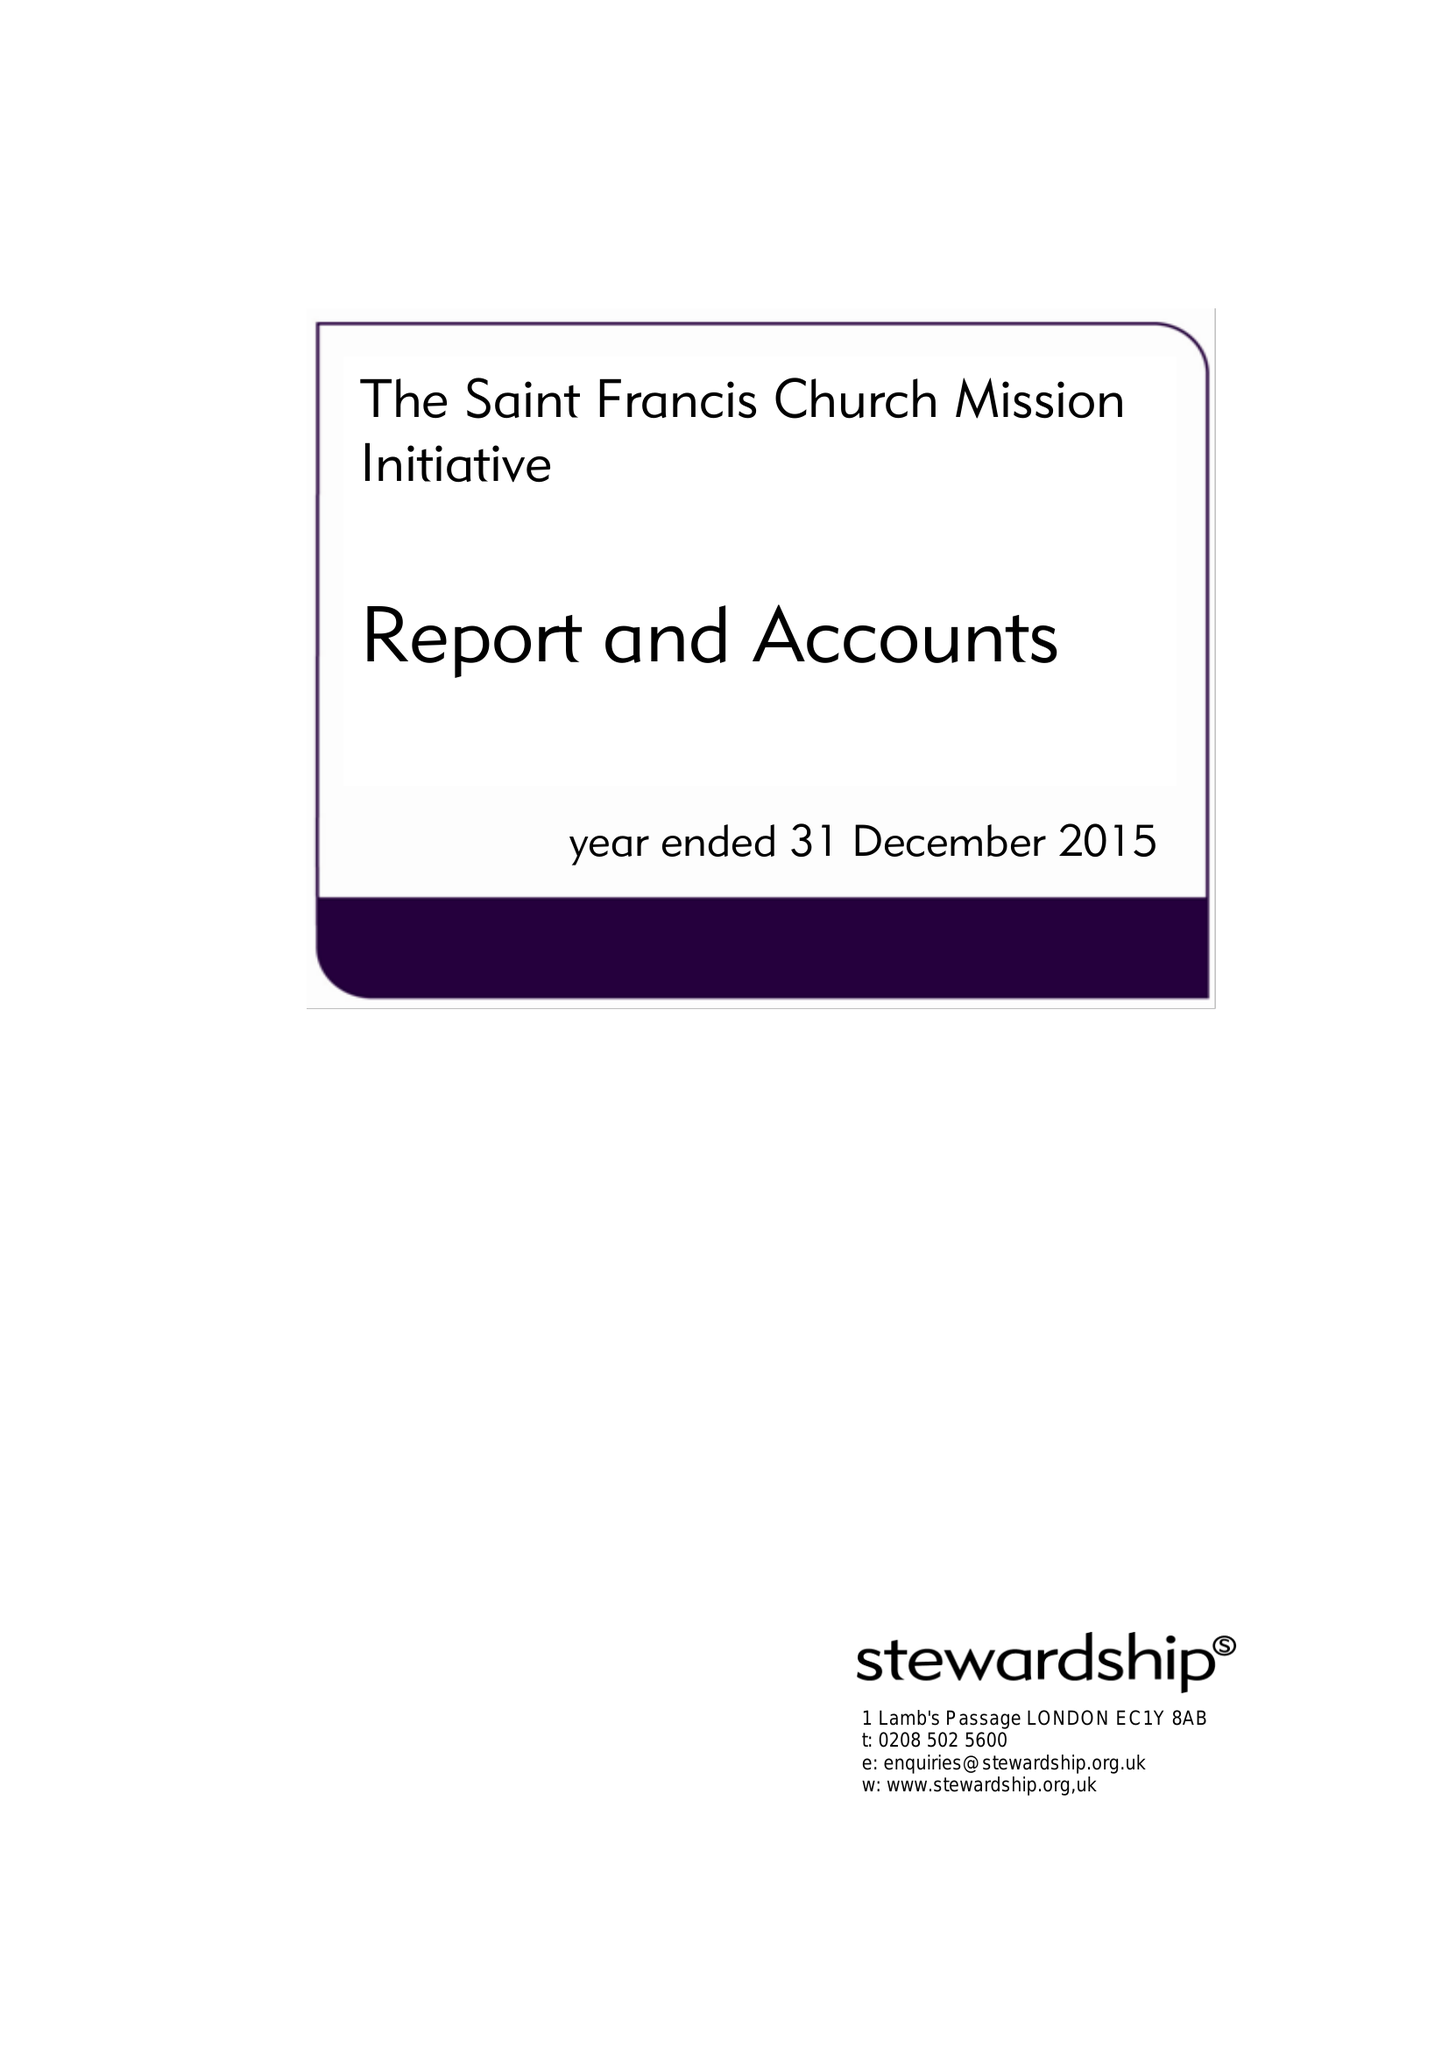What is the value for the address__street_line?
Answer the question using a single word or phrase. DALGARNO WAY 